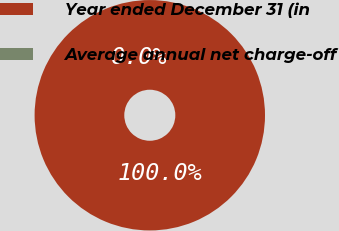Convert chart to OTSL. <chart><loc_0><loc_0><loc_500><loc_500><pie_chart><fcel>Year ended December 31 (in<fcel>Average annual net charge-off<nl><fcel>100.0%<fcel>0.0%<nl></chart> 